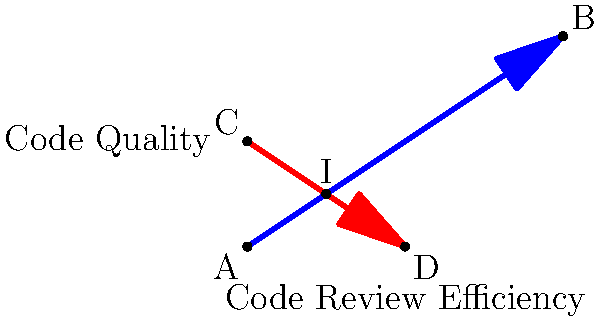In a coordinate system representing code review perspectives, two lines intersect: the "Code Review Efficiency" line passes through points A(0,0) and B(6,4), while the "Code Quality" line passes through points C(0,2) and D(3,0). Calculate the coordinates of the intersection point I, which represents the optimal balance between efficiency and quality in code reviews. To find the intersection point, we need to:

1. Find the equations of both lines
2. Solve the system of equations

Step 1: Find the equations of the lines

For line AB (Code Review Efficiency):
Slope = $m_{AB} = \frac{4-0}{6-0} = \frac{2}{3}$
Equation: $y = \frac{2}{3}x$

For line CD (Code Quality):
Slope = $m_{CD} = \frac{0-2}{3-0} = -\frac{2}{3}$
Equation: $y = -\frac{2}{3}x + 2$

Step 2: Solve the system of equations

$$\begin{cases}
y = \frac{2}{3}x \\
y = -\frac{2}{3}x + 2
\end{cases}$$

Equating the right-hand sides:
$\frac{2}{3}x = -\frac{2}{3}x + 2$

Solving for x:
$\frac{4}{3}x = 2$
$x = \frac{3}{2} = 1.5$

Substituting x back into either equation:
$y = \frac{2}{3}(1.5) = 1$

Therefore, the intersection point I has coordinates (1.5, 1).
Answer: (1.5, 1) 